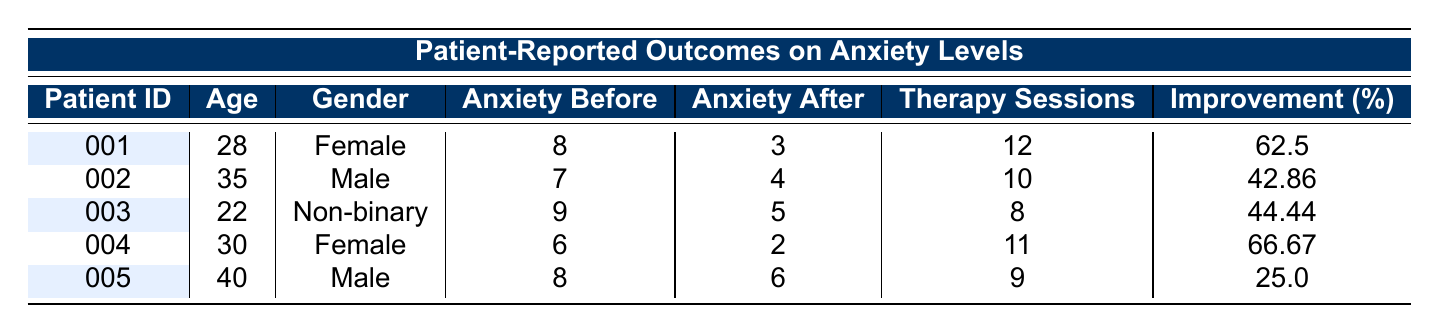What is the anxiety level before therapy for patient ID 001? According to the table, the anxiety level before therapy for patient ID 001 is provided directly in the column labeled "Anxiety Before." The entry for patient ID 001 shows a value of 8.
Answer: 8 What is the improvement percentage for patient ID 004? The improvement percentage for patient ID 004 is listed directly in the column labeled "Improvement (%)". The entry for patient ID 004 shows a value of 66.67.
Answer: 66.67 How many therapy sessions did patient ID 002 attend? The table contains a specific column for "Therapy Sessions," where the value corresponding to patient ID 002 indicates he attended 10 therapy sessions.
Answer: 10 What is the average anxiety level after therapy for all patients? To find the average anxiety level after therapy, we sum the "Anxiety After" values: (3 + 4 + 5 + 2 + 6) = 20. Since there are 5 patients, we divide by 5: 20 / 5 = 4.
Answer: 4 Is the anxiety level after therapy higher for male patients compared to female patients? We can analyze the patients’ anxiety levels after therapy. Male patients (ID 002 and ID 005) have levels of 4 and 6, respectively, resulting in an average of (4 + 6) / 2 = 5. Female patients (ID 001 and ID 004) have levels of 3 and 2, averaging (3 + 2) / 2 = 2.5. Since 5 is greater than 2.5, the statement is true.
Answer: Yes Which patient showed the highest improvement percentage? By examining the "Improvement (%)" column, we see patient ID 004 has the highest percentage of improvement at 66.67, while the others are lower.
Answer: 004 What was the anxiety level after therapy for the youngest patient? The youngest patient is patient ID 003, who is 22 years old. The corresponding anxiety level after therapy is shown in the table as 5.
Answer: 5 How many patients reported an anxiety level of 6 after therapy? Looking at the "Anxiety After" column, only patient ID 005 has a post-therapy anxiety level of 6. Therefore, there is one patient.
Answer: 1 Which gender had the most therapy sessions on average? To find the averages, we calculate for each gender: Females (ID 001 and ID 004) attended (12 + 11) / 2 = 11.5 sessions, Males (ID 002 and ID 005) attended (10 + 9) / 2 = 9.5 sessions. Since 11.5 is greater than 9.5, females had more sessions on average.
Answer: Female 